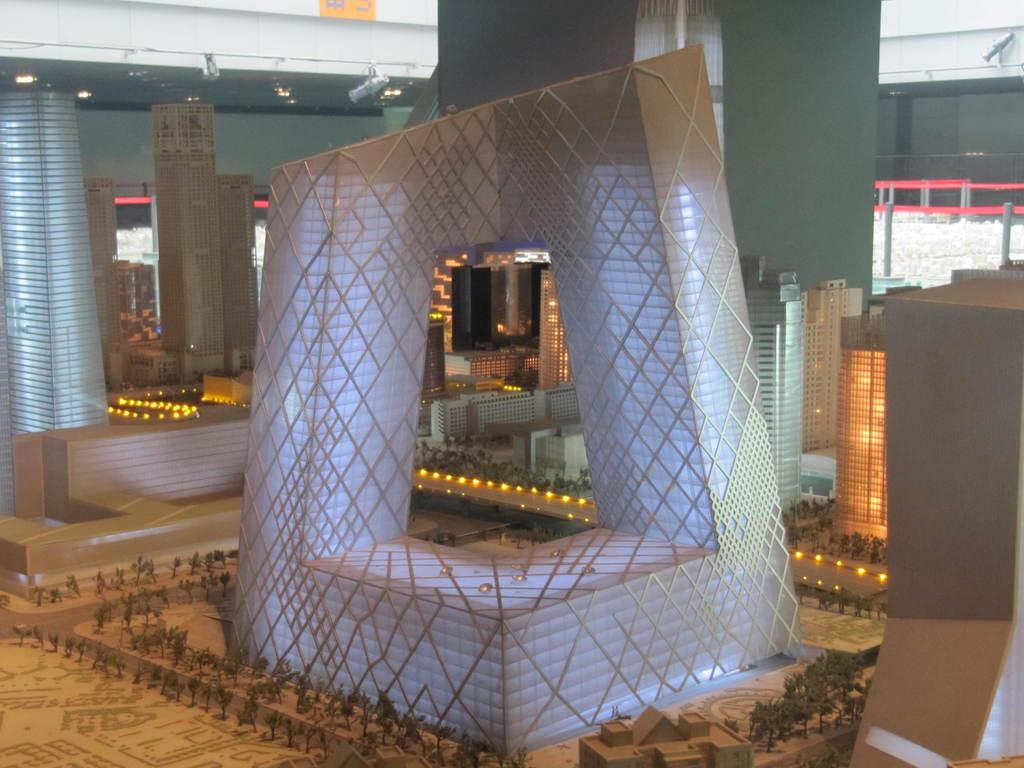What type of toys are present in the image? There are toys of buildings and trees in the image. Can you describe any other objects on the ground in the image? There are other objects on the ground in the image, but their specific details are not mentioned in the provided facts. What type of poison is being used by the police in the image? There is no mention of poison or police in the image; it features toys of buildings and trees. 